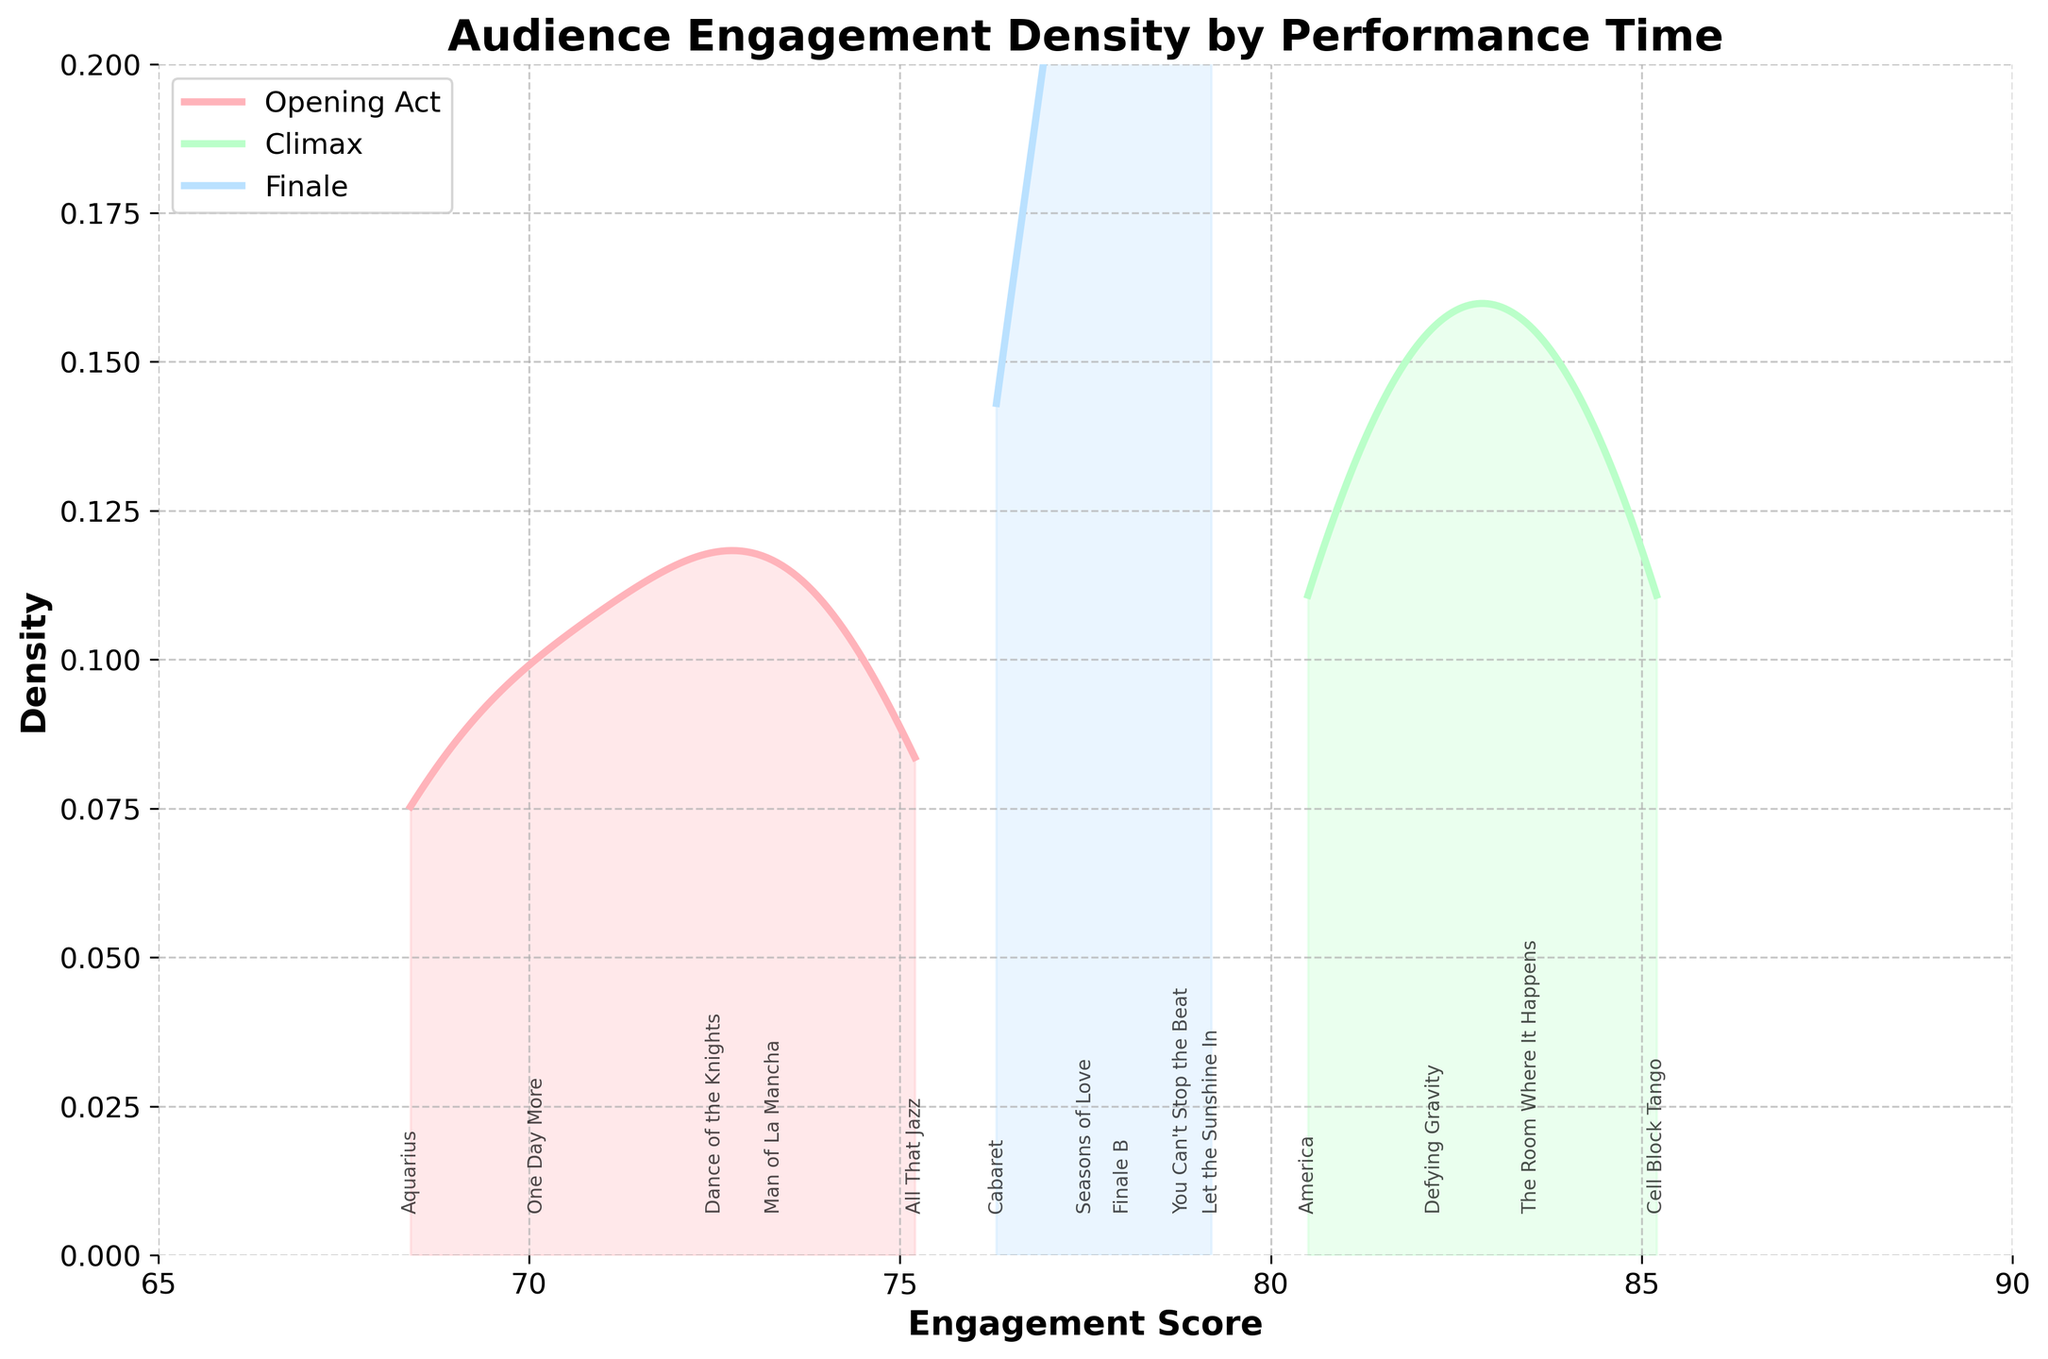What is the title of the figure? The titles are usually found at the top of the figure. The title here is "Audience Engagement Density by Performance Time".
Answer: Audience Engagement Density by Performance Time Which performance time has the highest peak density? By visually inspecting the density plot, we identify which curve has the highest peak. The Climax section has the highest peak density.
Answer: Climax Where is the peak density point for the Opening Act? To find the peak density point for the Opening Act, locate the highest point on the line representing Opening Act (usually the darkest shaded region) along the x-axis. This peak occurs around the 72-75 engagement score range.
Answer: Around 74 What's the range of engagement scores covered in the Opening Act? The range of engagement scores for the Opening Act is determined by identifying the minimum and maximum values along the x-axis where the Opening Act density appears. The range is 68.4 to 75.2.
Answer: 68.4 to 75.2 Which dance number in the Climax has the highest engagement score? Find the specific dance numbers positioned along the x-axis under the Climax distribution curve. The highest engagement score within the Climax section can be identified as 85.2 for Cell Block Tango.
Answer: Cell Block Tango How do engagement scores of the Finale compare to the Opening Act? Compare the location and shapes of both the Finale and Opening Act curves. The Finale shows higher engagement scores, mostly in the 76-79 range, compared to the Opening Act mostly in the 68-75 range.
Answer: Higher in the Finale What is the overall trend in engagement scores from Opening Act to Finale? Observing the shift in density distributions from left to right for Opening Act, Climax and Finale. The trend shows increasing engagement scores, peaking at Climax, then slightly decreasing in Finale.
Answer: Increases then slightly decreases Which performance time has the most spread-out engagement scores? By looking at the width of the density curves, we can determine which has the most spread. The Opening Act has the widest spread, indicating more variability in engagement scores.
Answer: Opening Act How many dance numbers are annotated on the plot? Counting the unique annotations for dance numbers on the plot. There are 14 dance numbers annotated.
Answer: 14 What does an engagement score density curve tell us about the dance numbers? A density curve indicates how engagement scores are distributed among the dance numbers. Higher peaks suggest many dance numbers have scores around the peak value, while broader curves indicate more variability.
Answer: Distribution of scores and variability 